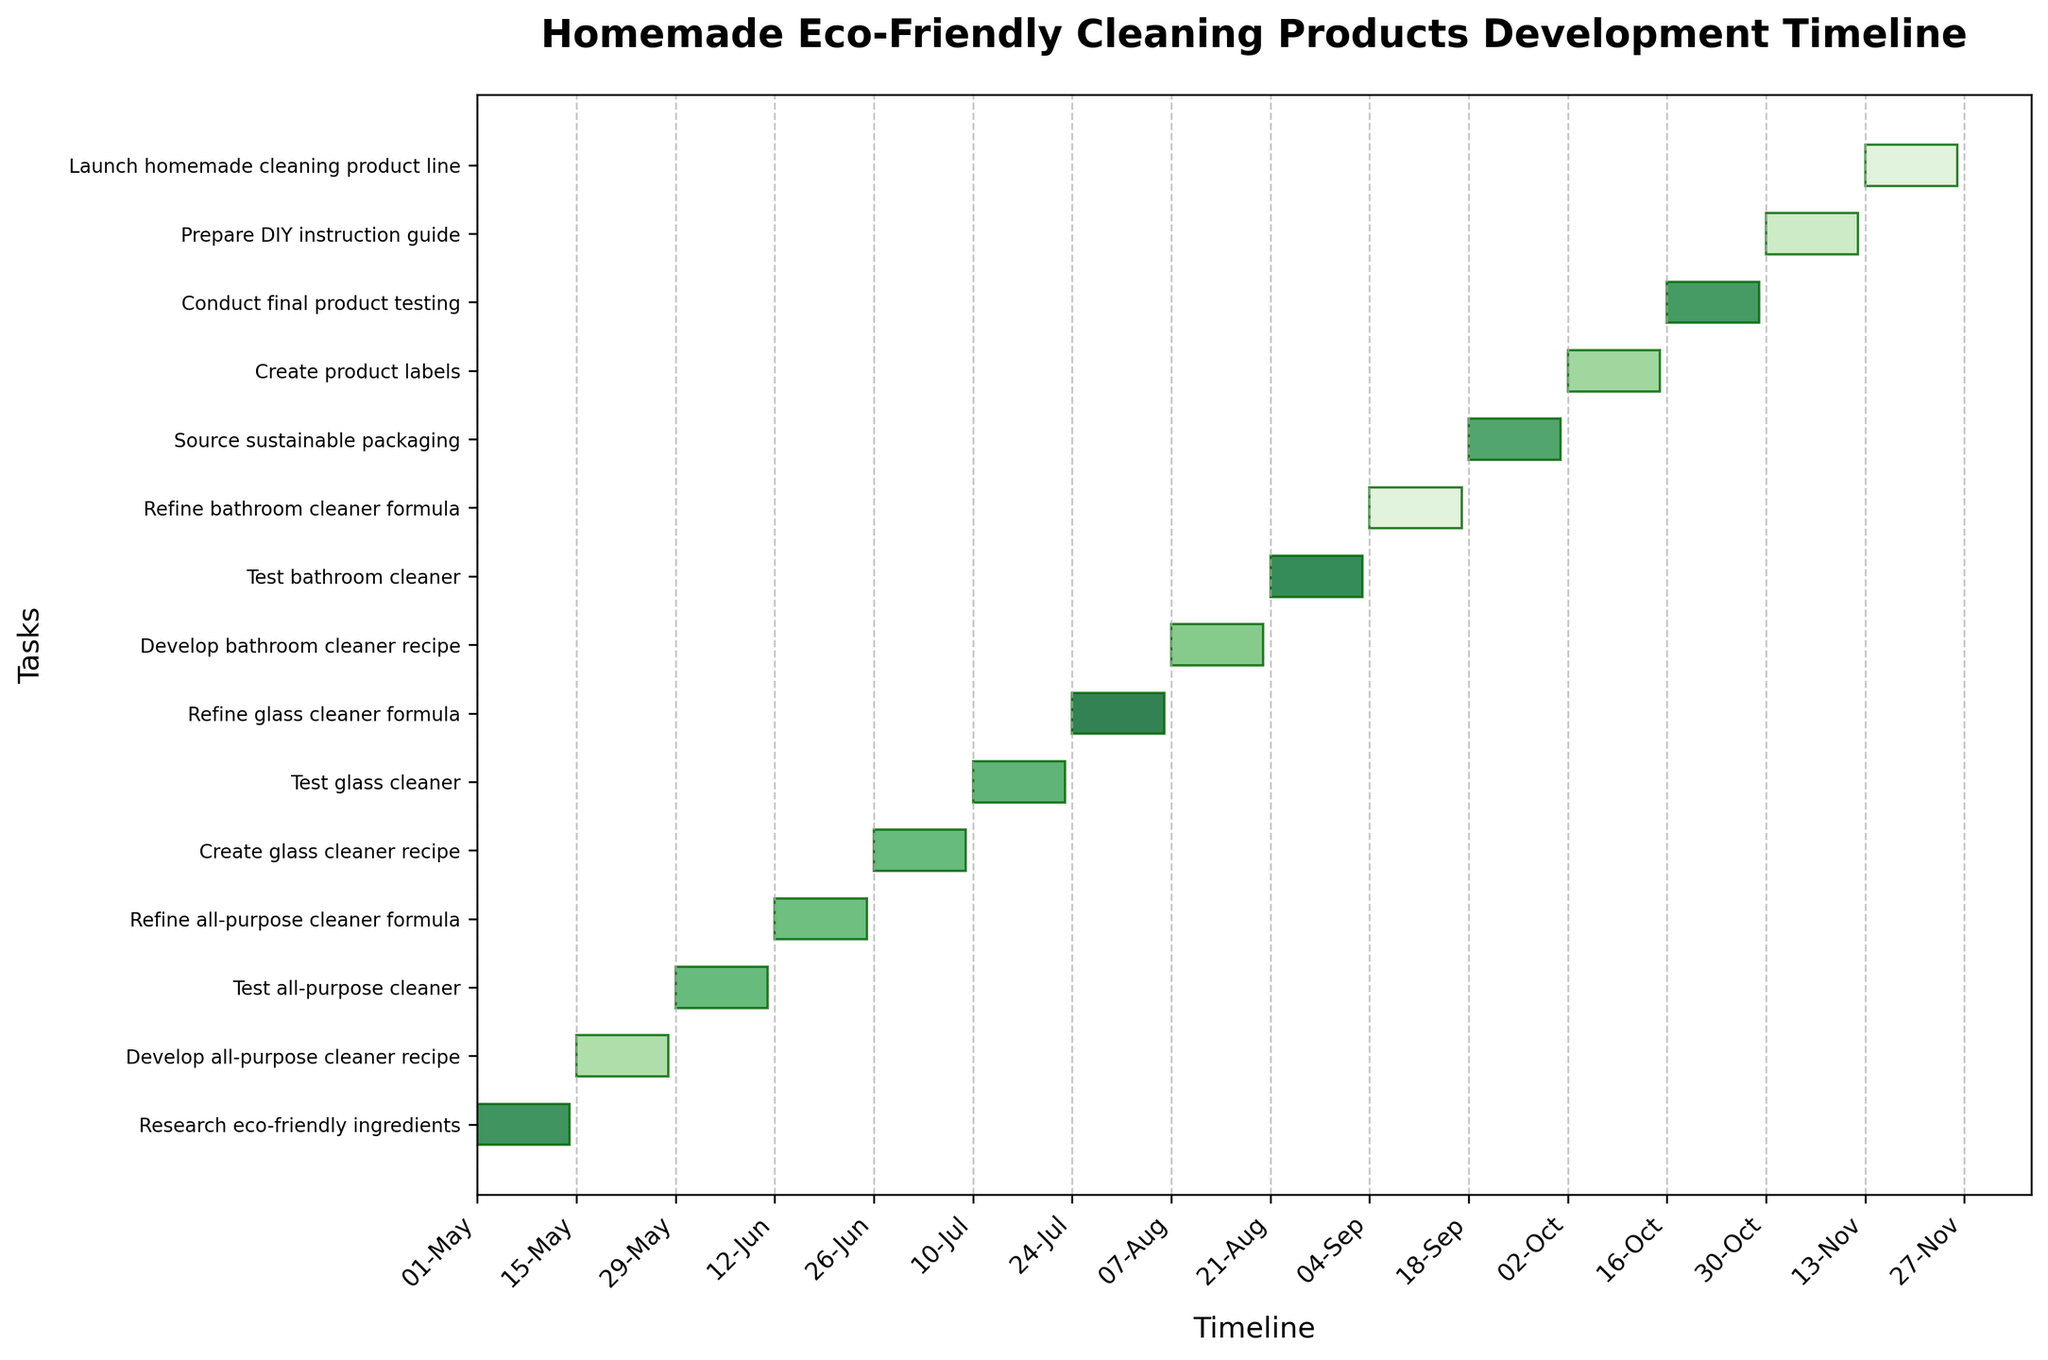Which task starts the timeline? The timeline's first task is the one positioned at the top of the Gantt chart as it usually follows the start date order. Looking at the top task, it reads "Research eco-friendly ingredients".
Answer: Research eco-friendly ingredients How long does the "Test all-purpose cleaner" phase last? On the Gantt chart, find the duration between the start and end dates visually marked by the horizontal bar for the "Test all-purpose cleaner" phase. It is from 2023-05-29 to 2023-06-11, which is 13 days (excluding the start date).
Answer: 13 days Which phase immediately follows the development of the glass cleaner recipe? Locate "Create glass cleaner recipe" on the chart and identify the next task bar right below it. The immediate next phase is "Test glass cleaner".
Answer: Test glass cleaner How many testing phases are there in total? Count the number of tasks containing "Test" in their titles on the Gantt chart.
Answer: 3 When does the "Prepare DIY instruction guide" phase begin? Find the "Prepare DIY instruction guide" task on the y-axis and read its starting point along the x-axis timeline. It starts on 2023-10-30.
Answer: 2023-10-30 What is the total duration in days from the beginning of the first task to the launch date? Find the starting date of "Research eco-friendly ingredients" (2023-05-01) and the ending date of "Launch homemade cleaning product line" (2023-11-26). Calculate the days between these dates: from 2023-05-01 to 2023-11-26 is 210 days.
Answer: 210 days Which task spans the longest duration? Compare the duration lengths of all the horizontal bars representing each task. The longest bar represents "Research eco-friendly ingredients," lasting 14 days (2023-05-01 to 2023-05-14).
Answer: Research eco-friendly ingredients Are there any overlapping phases during testing and refinement? Scan for any horizontal bars that visually overlap during the testing and refinement phases, especially around marker points for their respective tasks. Notably, there is no overlap as all testing and refinement phases are sequential.
Answer: No How long is the refinement phase for the glass cleaner formula? Locate the task "Refine glass cleaner formula" in the Gantt chart and calculate the days between its start (2023-07-24) and end (2023-08-06) dates. It's a 13-day period (excluding the start date).
Answer: 13 days What is the total number of tasks in the cleaning product development timeline? Count the number of horizontal bars (each representing distinct tasks) on the Gantt chart.
Answer: 14 